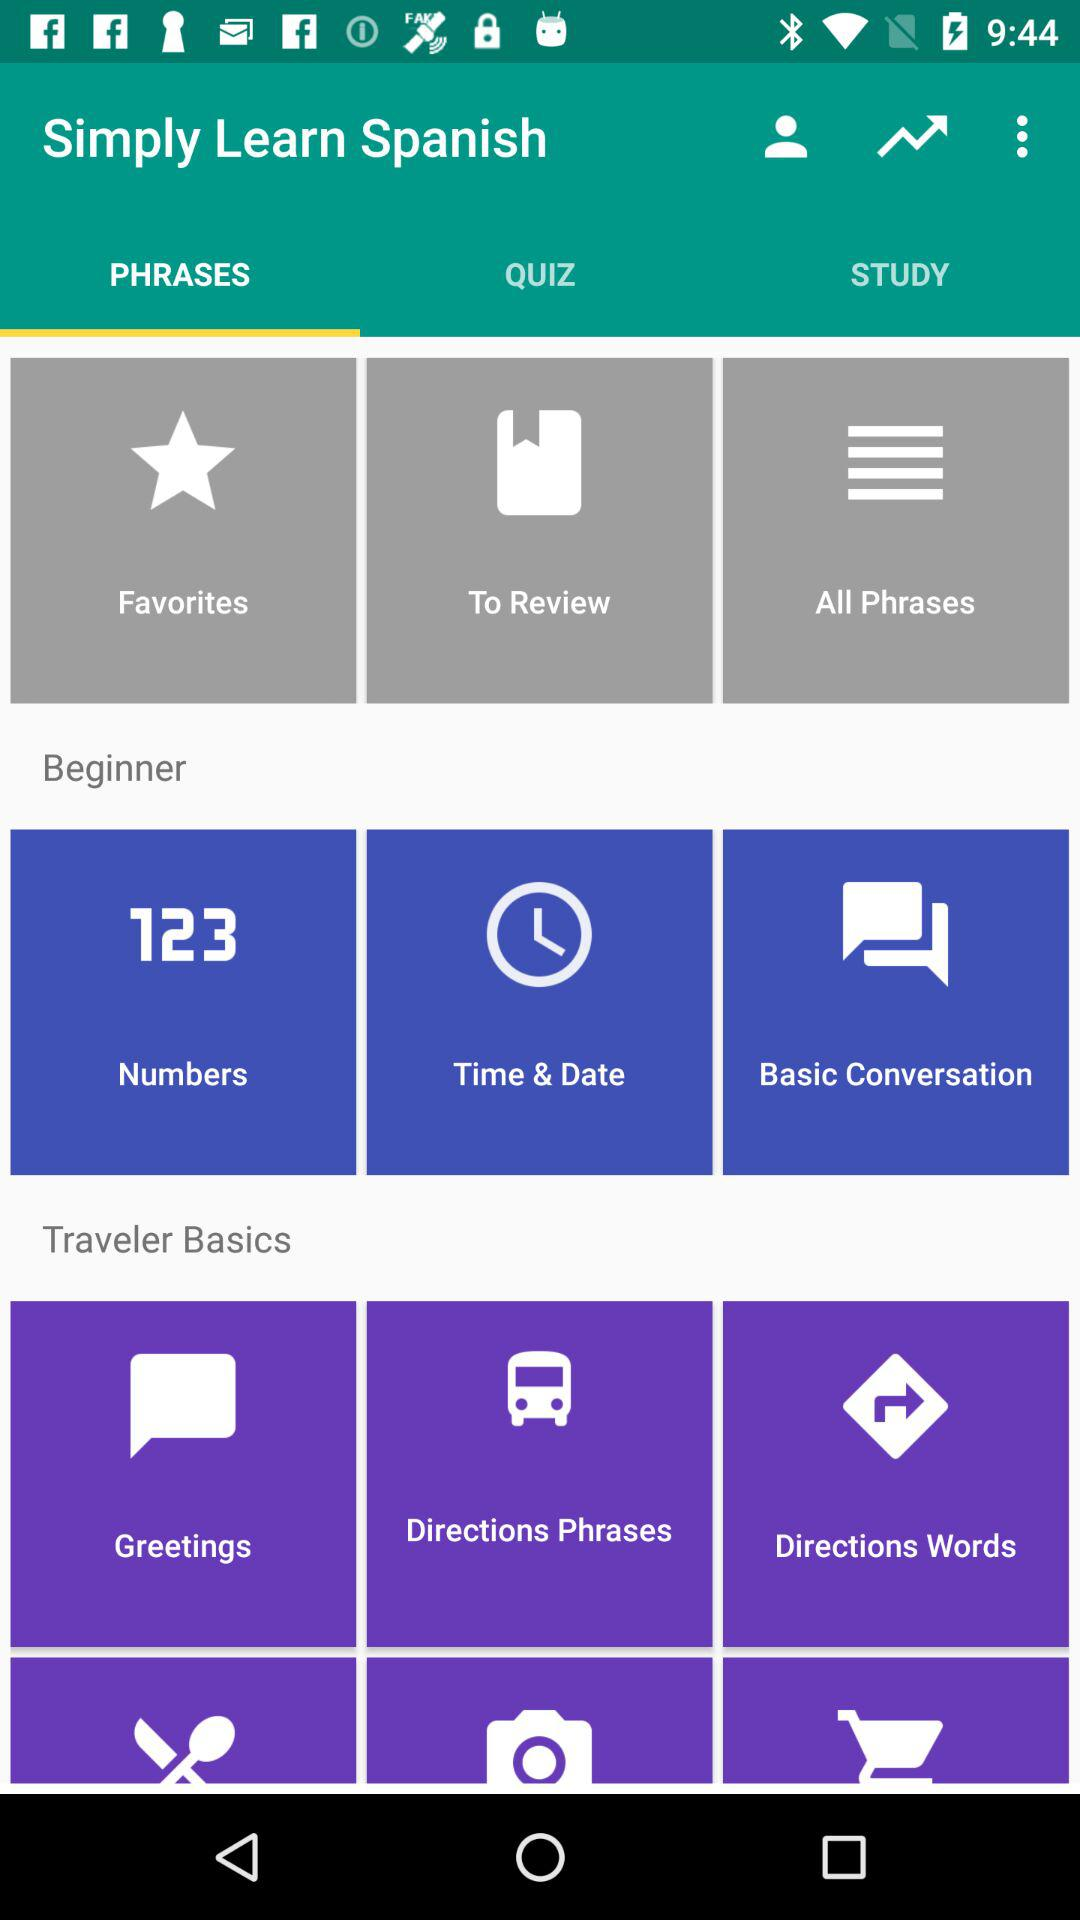Which option is selected? The selected option is "PHRASES". 